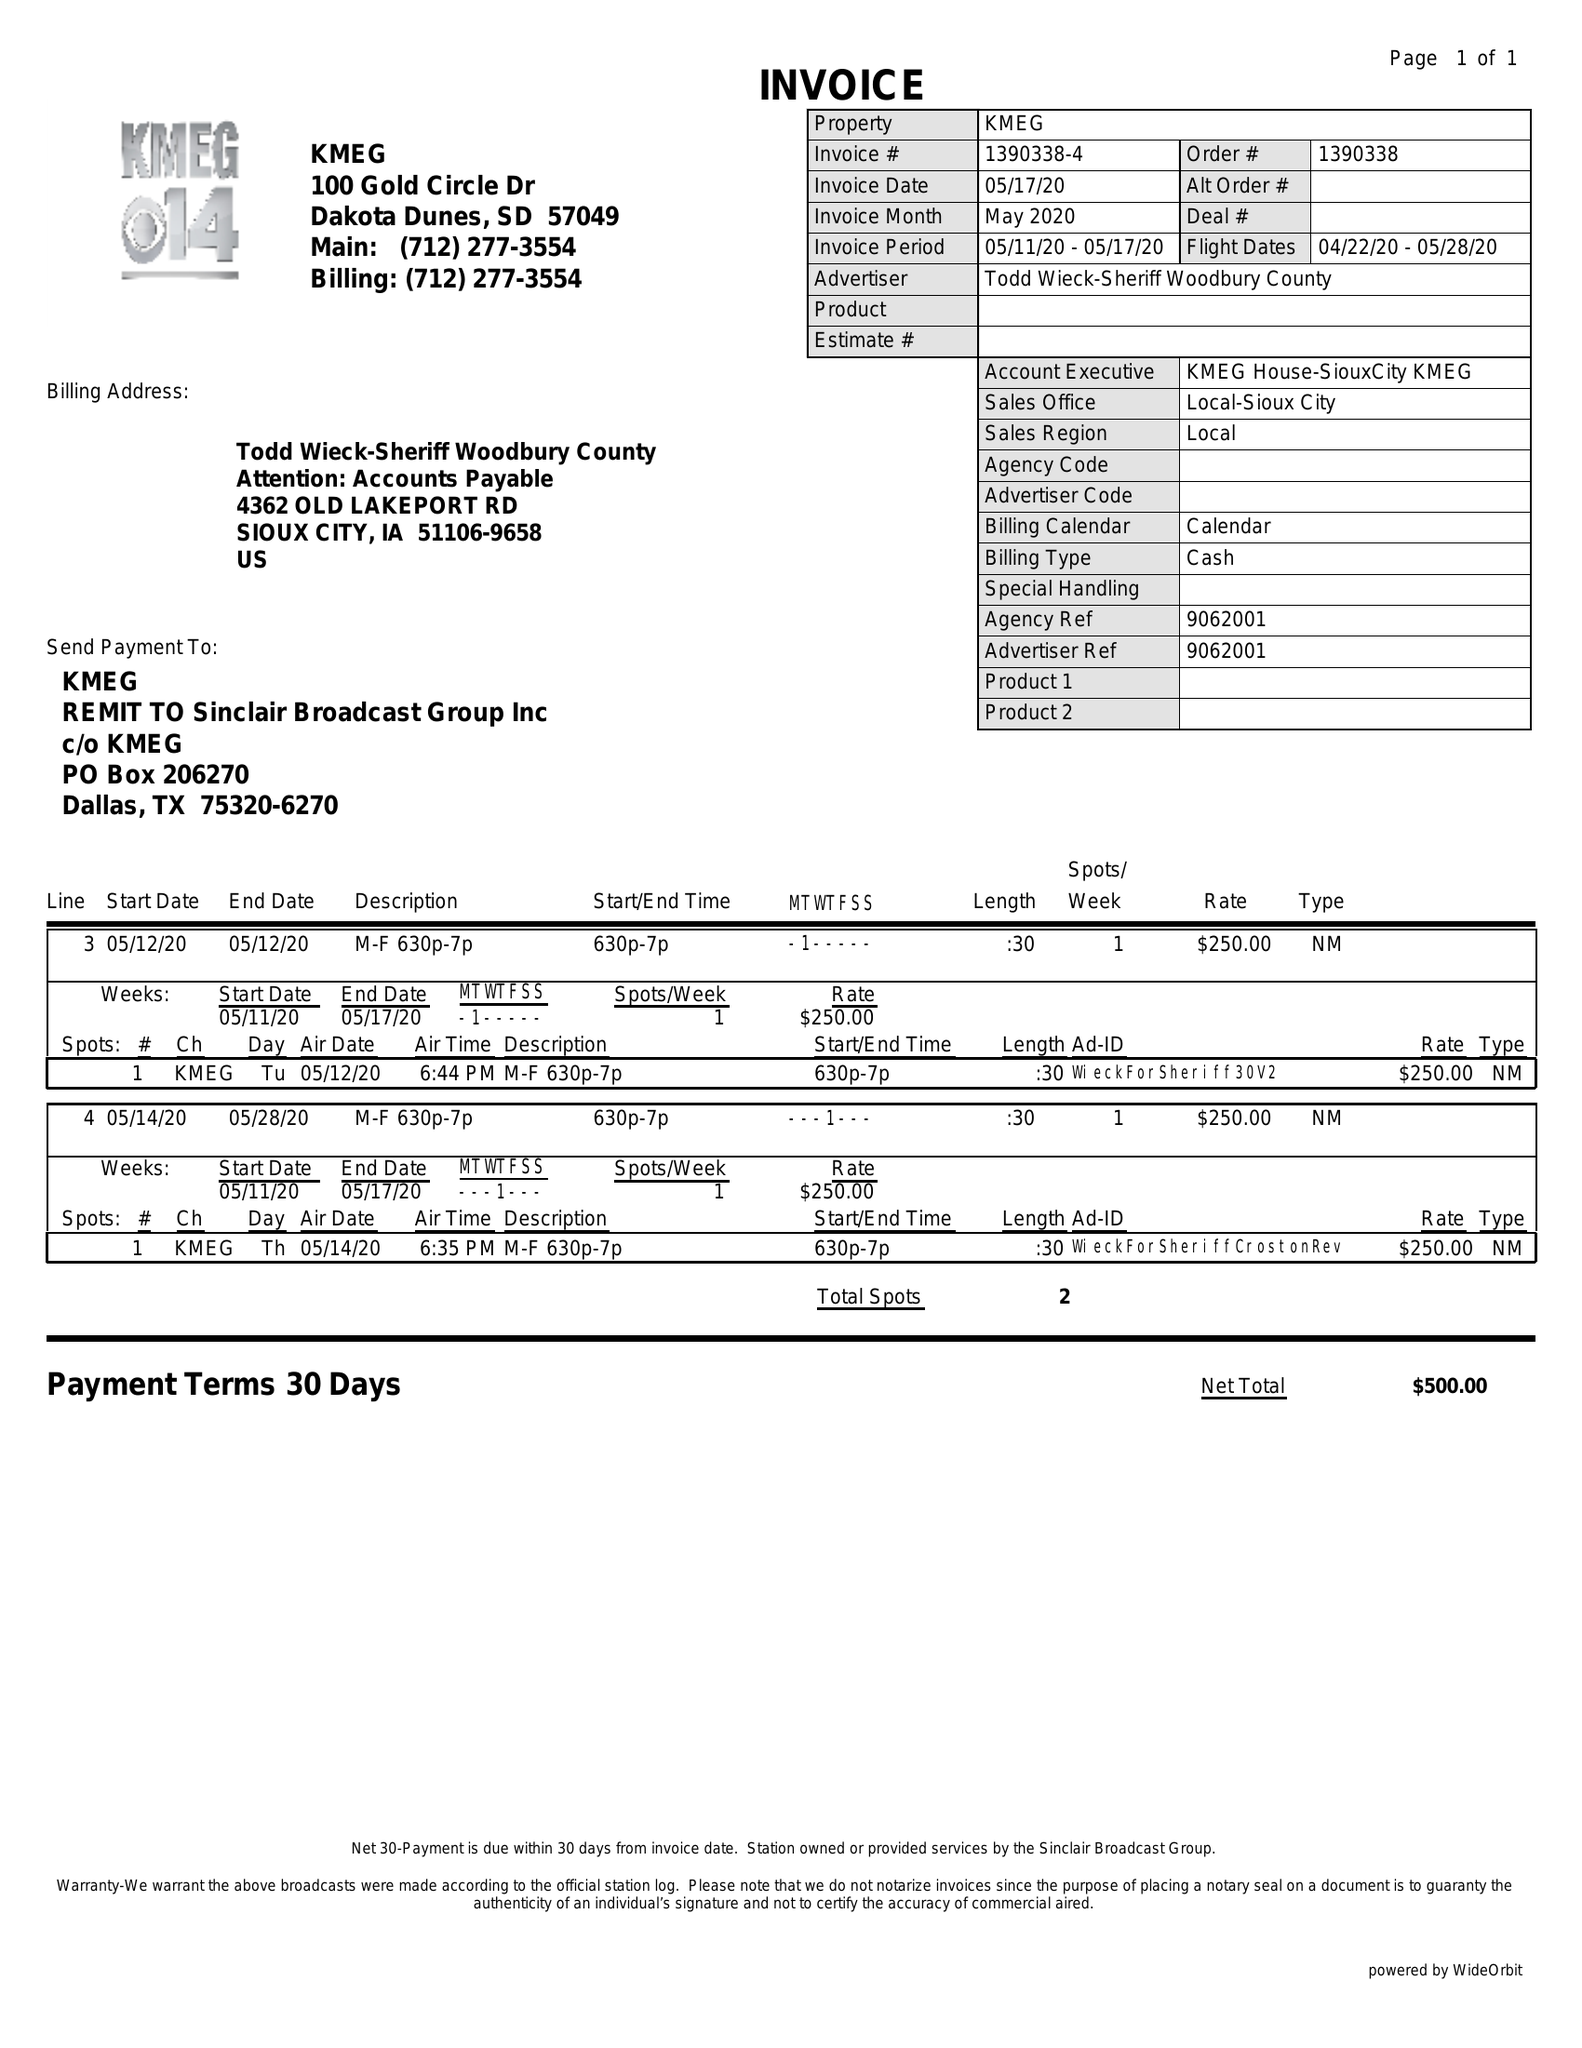What is the value for the flight_from?
Answer the question using a single word or phrase. 04/22/20 